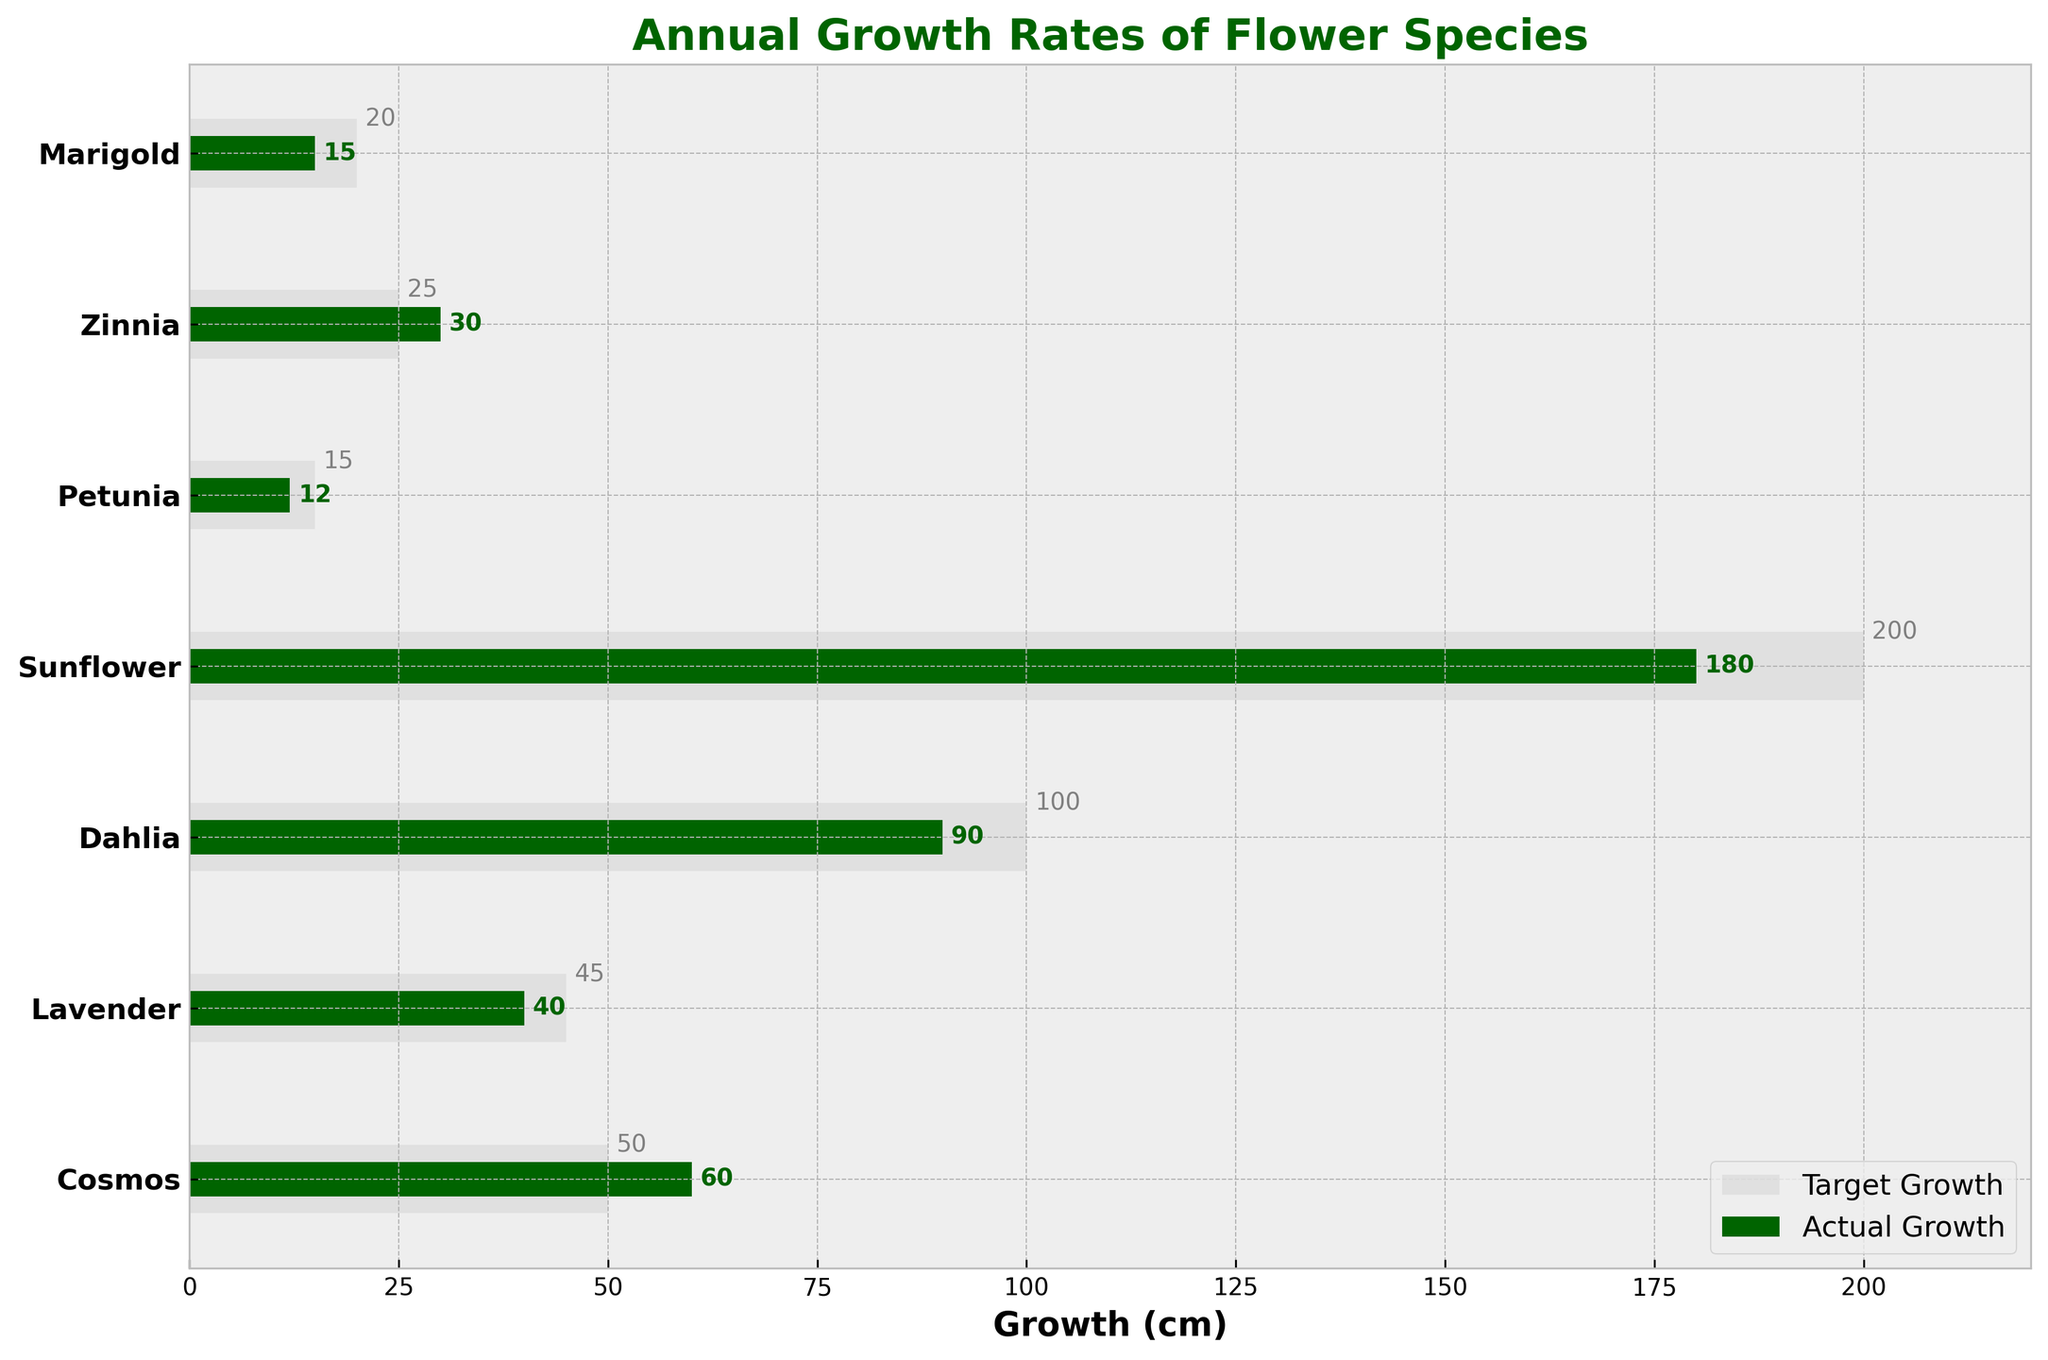What's the title of the figure? The title of the figure is displayed at the top, indicating what the chart represents. It helps to understand the context of the data.
Answer: Annual Growth Rates of Flower Species What is the actual growth for Marigold? Locate the Marigold bar in the chart. The actual growth is represented by the shorter dark green bar.
Answer: 15 cm How does Sunflower's target growth compare to its actual growth? Compare the length of the light gray bar (target growth) with the dark green bar (actual growth) for Sunflower.
Answer: Target: 200 cm, Actual: 180 cm Which flower species has the smallest difference between actual and target growth? Calculate the differences for each species by subtracting actual growth from target growth, then identify the smallest difference.
Answer: Zinnia How many flower species achieved or exceeded their target growth? Count the species where the actual growth (dark green bar) meets or surpasses the target growth (light gray bar).
Answer: 2 (Zinnia and Cosmos) Which flower species has the highest actual growth? Look for the longest dark green bar among all species, indicating the highest actual growth.
Answer: Sunflower What is the average target growth across all flower species? Sum the target growth values and divide by the number of species: (20 + 25 + 15 + 200 + 100 + 45 + 50) / 7.
Answer: 65.86 cm How much does Petunia need to grow to reach its target? Subtract Petunia's actual growth from its target growth: 15 cm - 12 cm.
Answer: 3 cm What is the difference in actual growth between Lavender and Cosmos? Subtract Lavender's actual growth from Cosmos's actual growth: 60 cm - 40 cm.
Answer: 20 cm Which species had an actual growth closest to its target growth? Find the species with the smallest absolute difference between the actual and target growth.
Answer: Zinnia 